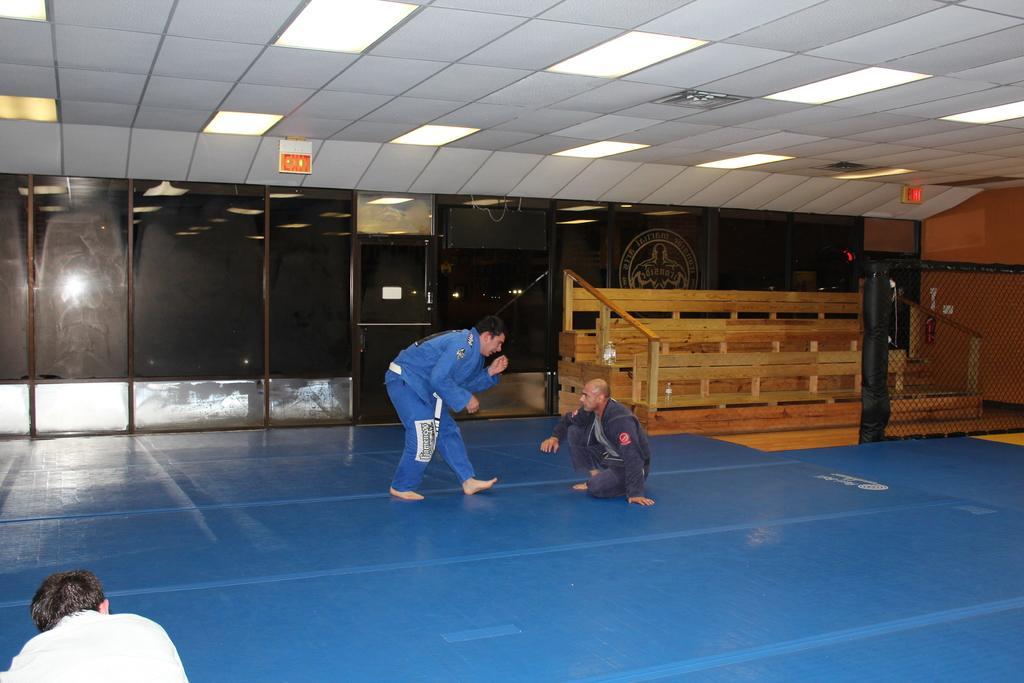How would you summarize this image in a sentence or two? In this image a person is standing on the floor. Before him there is a person. Right side there is a fence. Behind there are few benches. Background there is a wall having a painting of an image. Left bottom there is a person. Top of the image there are few lights attached to the roof. 